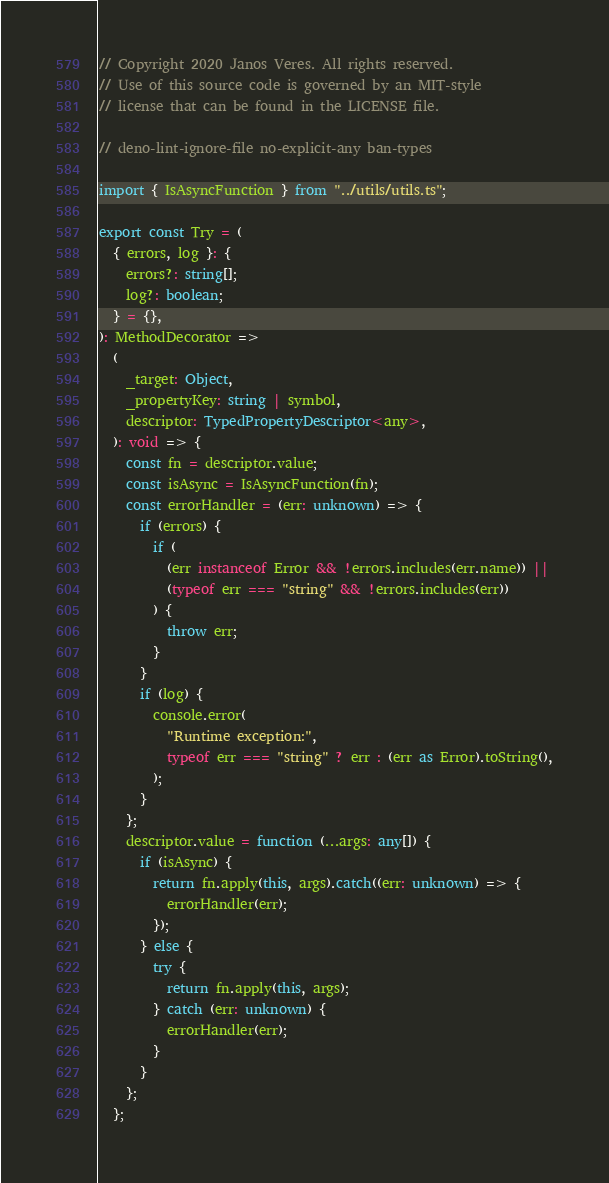<code> <loc_0><loc_0><loc_500><loc_500><_TypeScript_>// Copyright 2020 Janos Veres. All rights reserved.
// Use of this source code is governed by an MIT-style
// license that can be found in the LICENSE file.

// deno-lint-ignore-file no-explicit-any ban-types

import { IsAsyncFunction } from "../utils/utils.ts";

export const Try = (
  { errors, log }: {
    errors?: string[];
    log?: boolean;
  } = {},
): MethodDecorator =>
  (
    _target: Object,
    _propertyKey: string | symbol,
    descriptor: TypedPropertyDescriptor<any>,
  ): void => {
    const fn = descriptor.value;
    const isAsync = IsAsyncFunction(fn);
    const errorHandler = (err: unknown) => {
      if (errors) {
        if (
          (err instanceof Error && !errors.includes(err.name)) ||
          (typeof err === "string" && !errors.includes(err))
        ) {
          throw err;
        }
      }
      if (log) {
        console.error(
          "Runtime exception:",
          typeof err === "string" ? err : (err as Error).toString(),
        );
      }
    };
    descriptor.value = function (...args: any[]) {
      if (isAsync) {
        return fn.apply(this, args).catch((err: unknown) => {
          errorHandler(err);
        });
      } else {
        try {
          return fn.apply(this, args);
        } catch (err: unknown) {
          errorHandler(err);
        }
      }
    };
  };
</code> 